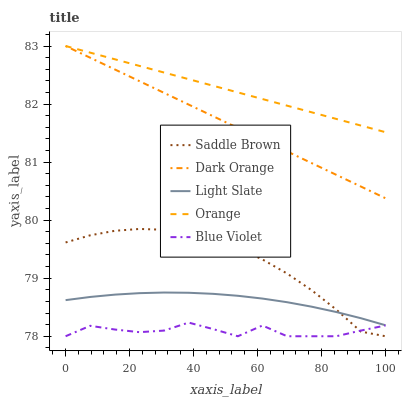Does Blue Violet have the minimum area under the curve?
Answer yes or no. Yes. Does Orange have the maximum area under the curve?
Answer yes or no. Yes. Does Dark Orange have the minimum area under the curve?
Answer yes or no. No. Does Dark Orange have the maximum area under the curve?
Answer yes or no. No. Is Dark Orange the smoothest?
Answer yes or no. Yes. Is Blue Violet the roughest?
Answer yes or no. Yes. Is Orange the smoothest?
Answer yes or no. No. Is Orange the roughest?
Answer yes or no. No. Does Saddle Brown have the lowest value?
Answer yes or no. Yes. Does Dark Orange have the lowest value?
Answer yes or no. No. Does Orange have the highest value?
Answer yes or no. Yes. Does Saddle Brown have the highest value?
Answer yes or no. No. Is Light Slate less than Orange?
Answer yes or no. Yes. Is Light Slate greater than Blue Violet?
Answer yes or no. Yes. Does Light Slate intersect Saddle Brown?
Answer yes or no. Yes. Is Light Slate less than Saddle Brown?
Answer yes or no. No. Is Light Slate greater than Saddle Brown?
Answer yes or no. No. Does Light Slate intersect Orange?
Answer yes or no. No. 